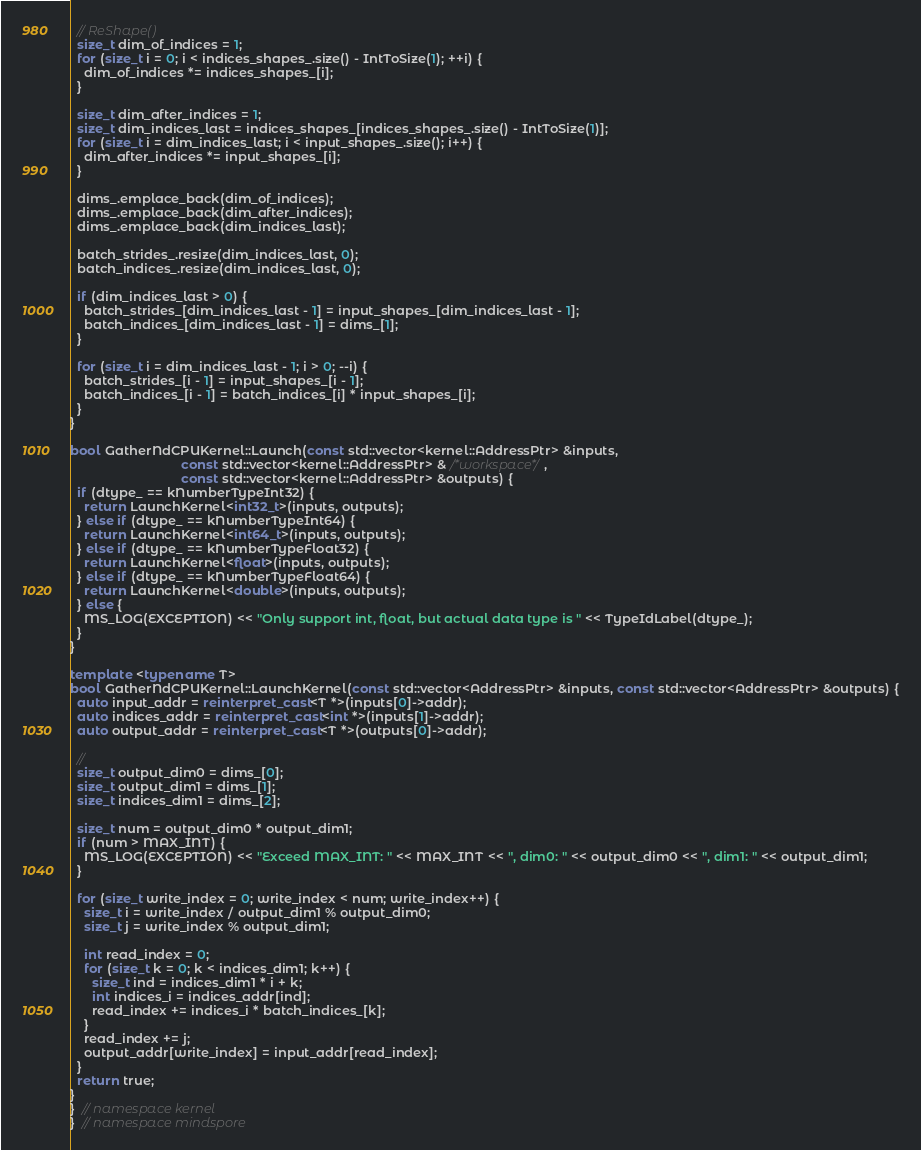<code> <loc_0><loc_0><loc_500><loc_500><_C++_>  // ReShape()
  size_t dim_of_indices = 1;
  for (size_t i = 0; i < indices_shapes_.size() - IntToSize(1); ++i) {
    dim_of_indices *= indices_shapes_[i];
  }

  size_t dim_after_indices = 1;
  size_t dim_indices_last = indices_shapes_[indices_shapes_.size() - IntToSize(1)];
  for (size_t i = dim_indices_last; i < input_shapes_.size(); i++) {
    dim_after_indices *= input_shapes_[i];
  }

  dims_.emplace_back(dim_of_indices);
  dims_.emplace_back(dim_after_indices);
  dims_.emplace_back(dim_indices_last);

  batch_strides_.resize(dim_indices_last, 0);
  batch_indices_.resize(dim_indices_last, 0);

  if (dim_indices_last > 0) {
    batch_strides_[dim_indices_last - 1] = input_shapes_[dim_indices_last - 1];
    batch_indices_[dim_indices_last - 1] = dims_[1];
  }

  for (size_t i = dim_indices_last - 1; i > 0; --i) {
    batch_strides_[i - 1] = input_shapes_[i - 1];
    batch_indices_[i - 1] = batch_indices_[i] * input_shapes_[i];
  }
}

bool GatherNdCPUKernel::Launch(const std::vector<kernel::AddressPtr> &inputs,
                               const std::vector<kernel::AddressPtr> & /*workspace*/,
                               const std::vector<kernel::AddressPtr> &outputs) {
  if (dtype_ == kNumberTypeInt32) {
    return LaunchKernel<int32_t>(inputs, outputs);
  } else if (dtype_ == kNumberTypeInt64) {
    return LaunchKernel<int64_t>(inputs, outputs);
  } else if (dtype_ == kNumberTypeFloat32) {
    return LaunchKernel<float>(inputs, outputs);
  } else if (dtype_ == kNumberTypeFloat64) {
    return LaunchKernel<double>(inputs, outputs);
  } else {
    MS_LOG(EXCEPTION) << "Only support int, float, but actual data type is " << TypeIdLabel(dtype_);
  }
}

template <typename T>
bool GatherNdCPUKernel::LaunchKernel(const std::vector<AddressPtr> &inputs, const std::vector<AddressPtr> &outputs) {
  auto input_addr = reinterpret_cast<T *>(inputs[0]->addr);
  auto indices_addr = reinterpret_cast<int *>(inputs[1]->addr);
  auto output_addr = reinterpret_cast<T *>(outputs[0]->addr);

  //
  size_t output_dim0 = dims_[0];
  size_t output_dim1 = dims_[1];
  size_t indices_dim1 = dims_[2];

  size_t num = output_dim0 * output_dim1;
  if (num > MAX_INT) {
    MS_LOG(EXCEPTION) << "Exceed MAX_INT: " << MAX_INT << ", dim0: " << output_dim0 << ", dim1: " << output_dim1;
  }

  for (size_t write_index = 0; write_index < num; write_index++) {
    size_t i = write_index / output_dim1 % output_dim0;
    size_t j = write_index % output_dim1;

    int read_index = 0;
    for (size_t k = 0; k < indices_dim1; k++) {
      size_t ind = indices_dim1 * i + k;
      int indices_i = indices_addr[ind];
      read_index += indices_i * batch_indices_[k];
    }
    read_index += j;
    output_addr[write_index] = input_addr[read_index];
  }
  return true;
}
}  // namespace kernel
}  // namespace mindspore
</code> 